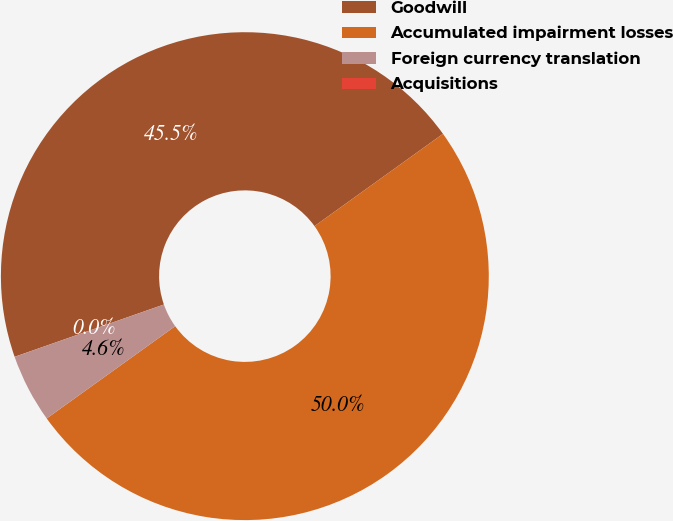Convert chart. <chart><loc_0><loc_0><loc_500><loc_500><pie_chart><fcel>Goodwill<fcel>Accumulated impairment losses<fcel>Foreign currency translation<fcel>Acquisitions<nl><fcel>45.45%<fcel>50.0%<fcel>4.55%<fcel>0.0%<nl></chart> 